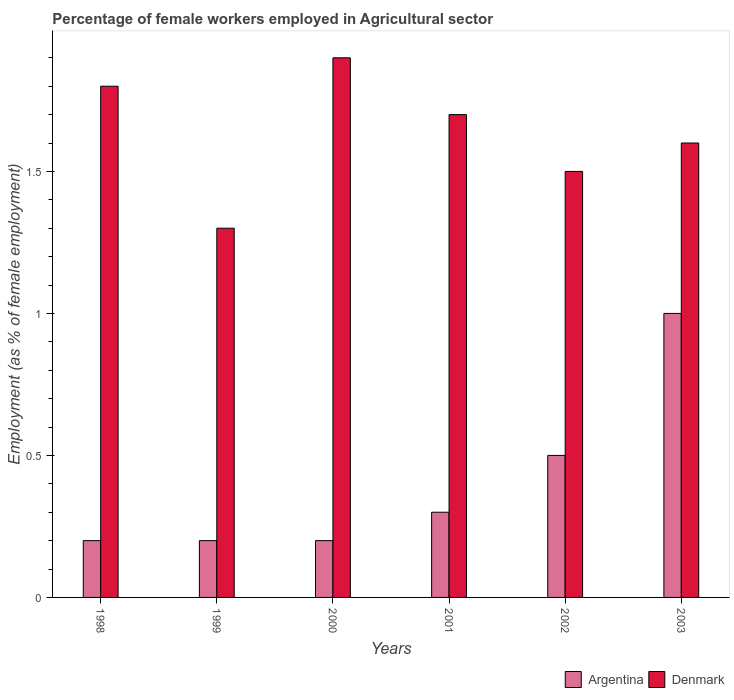How many different coloured bars are there?
Your response must be concise. 2. How many groups of bars are there?
Your answer should be very brief. 6. Are the number of bars on each tick of the X-axis equal?
Keep it short and to the point. Yes. How many bars are there on the 4th tick from the left?
Give a very brief answer. 2. How many bars are there on the 5th tick from the right?
Ensure brevity in your answer.  2. What is the percentage of females employed in Agricultural sector in Argentina in 1998?
Your response must be concise. 0.2. Across all years, what is the minimum percentage of females employed in Agricultural sector in Argentina?
Keep it short and to the point. 0.2. In which year was the percentage of females employed in Agricultural sector in Denmark maximum?
Make the answer very short. 2000. In which year was the percentage of females employed in Agricultural sector in Denmark minimum?
Offer a very short reply. 1999. What is the total percentage of females employed in Agricultural sector in Argentina in the graph?
Your response must be concise. 2.4. What is the difference between the percentage of females employed in Agricultural sector in Argentina in 1998 and that in 2002?
Your response must be concise. -0.3. What is the difference between the percentage of females employed in Agricultural sector in Argentina in 2003 and the percentage of females employed in Agricultural sector in Denmark in 1999?
Offer a very short reply. -0.3. What is the average percentage of females employed in Agricultural sector in Denmark per year?
Ensure brevity in your answer.  1.63. In the year 1999, what is the difference between the percentage of females employed in Agricultural sector in Argentina and percentage of females employed in Agricultural sector in Denmark?
Offer a very short reply. -1.1. In how many years, is the percentage of females employed in Agricultural sector in Denmark greater than 1.7 %?
Provide a succinct answer. 3. What is the ratio of the percentage of females employed in Agricultural sector in Argentina in 2001 to that in 2002?
Give a very brief answer. 0.6. What is the difference between the highest and the second highest percentage of females employed in Agricultural sector in Denmark?
Make the answer very short. 0.1. What is the difference between the highest and the lowest percentage of females employed in Agricultural sector in Argentina?
Keep it short and to the point. 0.8. Is the sum of the percentage of females employed in Agricultural sector in Argentina in 2001 and 2002 greater than the maximum percentage of females employed in Agricultural sector in Denmark across all years?
Your answer should be compact. No. What does the 2nd bar from the left in 2000 represents?
Your answer should be compact. Denmark. What does the 1st bar from the right in 2001 represents?
Offer a terse response. Denmark. How many bars are there?
Offer a very short reply. 12. Does the graph contain grids?
Provide a short and direct response. No. What is the title of the graph?
Your answer should be compact. Percentage of female workers employed in Agricultural sector. Does "Marshall Islands" appear as one of the legend labels in the graph?
Ensure brevity in your answer.  No. What is the label or title of the Y-axis?
Your answer should be compact. Employment (as % of female employment). What is the Employment (as % of female employment) of Argentina in 1998?
Provide a short and direct response. 0.2. What is the Employment (as % of female employment) of Denmark in 1998?
Your answer should be compact. 1.8. What is the Employment (as % of female employment) of Argentina in 1999?
Give a very brief answer. 0.2. What is the Employment (as % of female employment) of Denmark in 1999?
Your answer should be very brief. 1.3. What is the Employment (as % of female employment) in Argentina in 2000?
Ensure brevity in your answer.  0.2. What is the Employment (as % of female employment) in Denmark in 2000?
Give a very brief answer. 1.9. What is the Employment (as % of female employment) in Argentina in 2001?
Your response must be concise. 0.3. What is the Employment (as % of female employment) of Denmark in 2001?
Give a very brief answer. 1.7. What is the Employment (as % of female employment) of Argentina in 2002?
Provide a succinct answer. 0.5. What is the Employment (as % of female employment) in Denmark in 2002?
Provide a short and direct response. 1.5. What is the Employment (as % of female employment) of Argentina in 2003?
Ensure brevity in your answer.  1. What is the Employment (as % of female employment) in Denmark in 2003?
Keep it short and to the point. 1.6. Across all years, what is the maximum Employment (as % of female employment) in Denmark?
Ensure brevity in your answer.  1.9. Across all years, what is the minimum Employment (as % of female employment) of Argentina?
Offer a terse response. 0.2. Across all years, what is the minimum Employment (as % of female employment) in Denmark?
Offer a terse response. 1.3. What is the total Employment (as % of female employment) in Argentina in the graph?
Offer a terse response. 2.4. What is the total Employment (as % of female employment) of Denmark in the graph?
Provide a short and direct response. 9.8. What is the difference between the Employment (as % of female employment) in Argentina in 1998 and that in 1999?
Provide a short and direct response. 0. What is the difference between the Employment (as % of female employment) in Denmark in 1998 and that in 1999?
Your response must be concise. 0.5. What is the difference between the Employment (as % of female employment) of Denmark in 1998 and that in 2000?
Your response must be concise. -0.1. What is the difference between the Employment (as % of female employment) of Argentina in 1998 and that in 2002?
Offer a terse response. -0.3. What is the difference between the Employment (as % of female employment) in Denmark in 1998 and that in 2002?
Provide a short and direct response. 0.3. What is the difference between the Employment (as % of female employment) in Argentina in 1998 and that in 2003?
Your answer should be compact. -0.8. What is the difference between the Employment (as % of female employment) of Argentina in 1999 and that in 2000?
Ensure brevity in your answer.  0. What is the difference between the Employment (as % of female employment) in Denmark in 1999 and that in 2001?
Make the answer very short. -0.4. What is the difference between the Employment (as % of female employment) of Argentina in 1999 and that in 2003?
Offer a very short reply. -0.8. What is the difference between the Employment (as % of female employment) of Denmark in 1999 and that in 2003?
Give a very brief answer. -0.3. What is the difference between the Employment (as % of female employment) of Argentina in 2000 and that in 2002?
Make the answer very short. -0.3. What is the difference between the Employment (as % of female employment) of Denmark in 2000 and that in 2003?
Provide a short and direct response. 0.3. What is the difference between the Employment (as % of female employment) in Argentina in 2001 and that in 2003?
Offer a very short reply. -0.7. What is the difference between the Employment (as % of female employment) of Argentina in 2002 and that in 2003?
Your answer should be very brief. -0.5. What is the difference between the Employment (as % of female employment) in Argentina in 1998 and the Employment (as % of female employment) in Denmark in 2000?
Offer a terse response. -1.7. What is the difference between the Employment (as % of female employment) of Argentina in 1998 and the Employment (as % of female employment) of Denmark in 2002?
Offer a very short reply. -1.3. What is the difference between the Employment (as % of female employment) in Argentina in 1999 and the Employment (as % of female employment) in Denmark in 2001?
Offer a terse response. -1.5. What is the difference between the Employment (as % of female employment) in Argentina in 1999 and the Employment (as % of female employment) in Denmark in 2002?
Provide a succinct answer. -1.3. What is the difference between the Employment (as % of female employment) in Argentina in 2000 and the Employment (as % of female employment) in Denmark in 2001?
Ensure brevity in your answer.  -1.5. What is the difference between the Employment (as % of female employment) of Argentina in 2000 and the Employment (as % of female employment) of Denmark in 2002?
Offer a very short reply. -1.3. What is the difference between the Employment (as % of female employment) in Argentina in 2000 and the Employment (as % of female employment) in Denmark in 2003?
Your answer should be compact. -1.4. What is the difference between the Employment (as % of female employment) of Argentina in 2001 and the Employment (as % of female employment) of Denmark in 2003?
Give a very brief answer. -1.3. What is the difference between the Employment (as % of female employment) of Argentina in 2002 and the Employment (as % of female employment) of Denmark in 2003?
Make the answer very short. -1.1. What is the average Employment (as % of female employment) of Denmark per year?
Provide a succinct answer. 1.63. In the year 1998, what is the difference between the Employment (as % of female employment) in Argentina and Employment (as % of female employment) in Denmark?
Offer a terse response. -1.6. In the year 2002, what is the difference between the Employment (as % of female employment) of Argentina and Employment (as % of female employment) of Denmark?
Keep it short and to the point. -1. What is the ratio of the Employment (as % of female employment) of Denmark in 1998 to that in 1999?
Offer a very short reply. 1.38. What is the ratio of the Employment (as % of female employment) of Argentina in 1998 to that in 2000?
Your answer should be compact. 1. What is the ratio of the Employment (as % of female employment) in Denmark in 1998 to that in 2000?
Provide a succinct answer. 0.95. What is the ratio of the Employment (as % of female employment) of Denmark in 1998 to that in 2001?
Provide a short and direct response. 1.06. What is the ratio of the Employment (as % of female employment) of Denmark in 1999 to that in 2000?
Provide a short and direct response. 0.68. What is the ratio of the Employment (as % of female employment) of Argentina in 1999 to that in 2001?
Keep it short and to the point. 0.67. What is the ratio of the Employment (as % of female employment) of Denmark in 1999 to that in 2001?
Offer a very short reply. 0.76. What is the ratio of the Employment (as % of female employment) of Denmark in 1999 to that in 2002?
Provide a succinct answer. 0.87. What is the ratio of the Employment (as % of female employment) in Denmark in 1999 to that in 2003?
Ensure brevity in your answer.  0.81. What is the ratio of the Employment (as % of female employment) of Argentina in 2000 to that in 2001?
Provide a short and direct response. 0.67. What is the ratio of the Employment (as % of female employment) in Denmark in 2000 to that in 2001?
Offer a terse response. 1.12. What is the ratio of the Employment (as % of female employment) in Denmark in 2000 to that in 2002?
Your answer should be compact. 1.27. What is the ratio of the Employment (as % of female employment) in Denmark in 2000 to that in 2003?
Keep it short and to the point. 1.19. What is the ratio of the Employment (as % of female employment) in Argentina in 2001 to that in 2002?
Ensure brevity in your answer.  0.6. What is the ratio of the Employment (as % of female employment) of Denmark in 2001 to that in 2002?
Keep it short and to the point. 1.13. What is the ratio of the Employment (as % of female employment) in Denmark in 2001 to that in 2003?
Offer a terse response. 1.06. What is the ratio of the Employment (as % of female employment) of Denmark in 2002 to that in 2003?
Make the answer very short. 0.94. What is the difference between the highest and the lowest Employment (as % of female employment) in Denmark?
Offer a terse response. 0.6. 